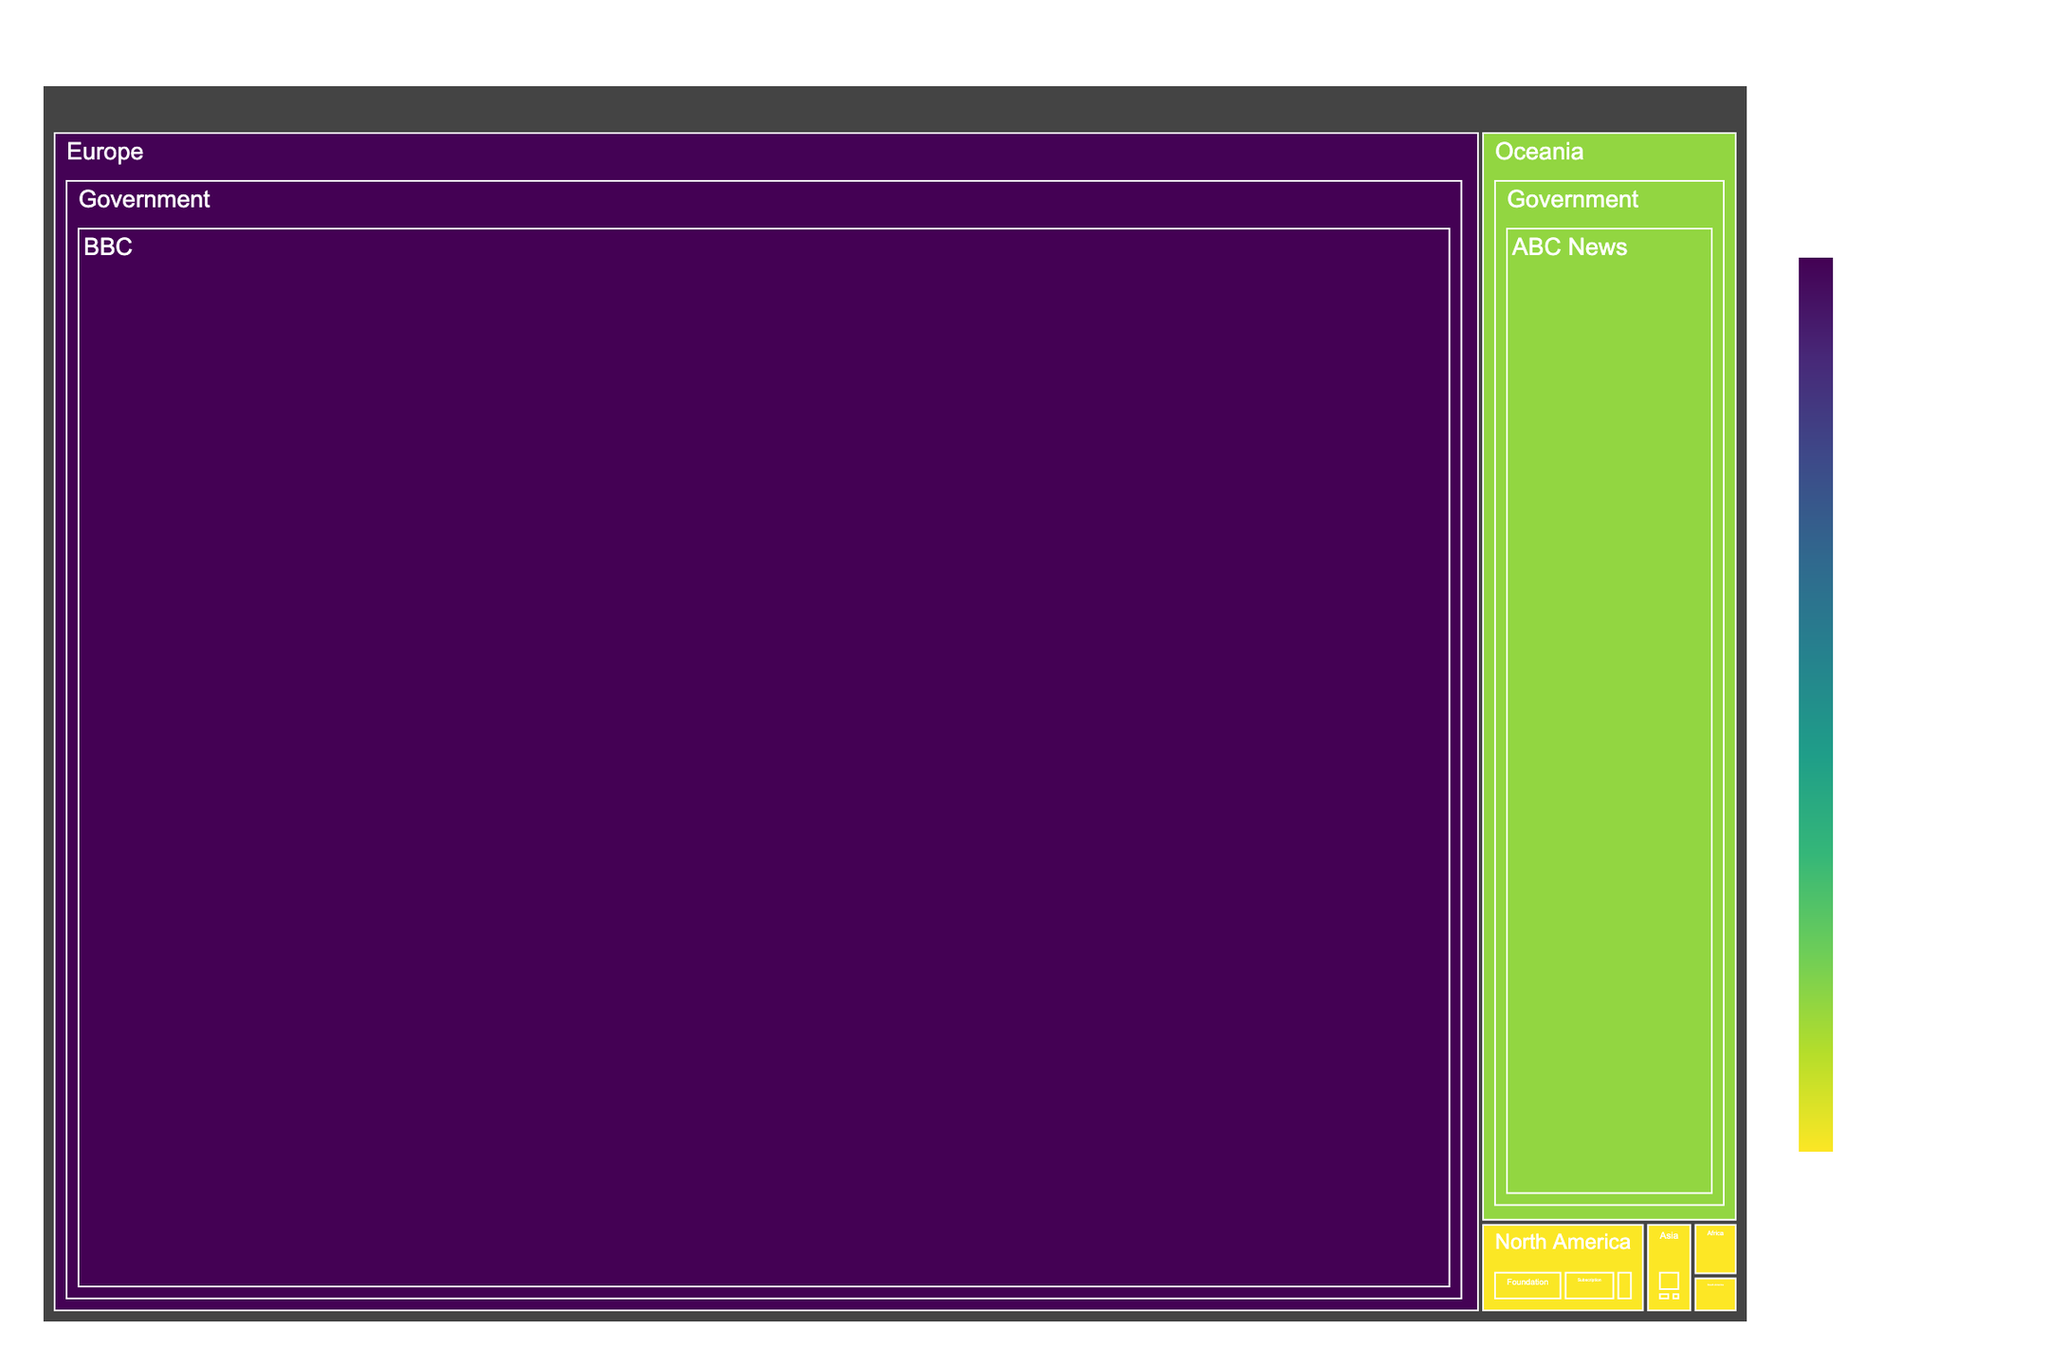what is the title of the figure? The title of a figure is usually found at the top of the figure and gives viewers an overview of what the figure represents. In this case, it reads "Funding Sources for Independent Media Outlets."
Answer: Funding Sources for Independent Media Outlets Which outlet received the highest amount of funding in the treemap? To find the outlet with the highest funding, locate the largest block on the treemap. This is usually the one with the highest value. The largest block in this case is the BBC from Europe under the Government category.
Answer: BBC How many categories of funding sources are represented in North America? To determine the number of categories, look at the different "Type" branches under the "North America" region. Here, North America has three categories: Foundation, Crowdfunding, and Subscription.
Answer: 3 What is the total funding amount for media outlets in Europe? Sum the funding amounts for all outlets located in Europe: BBC ($4,500,000,000), The Guardian ($12,000,000), and Correctiv ($3,000,000). The calculation is $4,500,000,000 + $12,000,000 + $3,000,000 which equals $4,515,000,000.
Answer: $4,515,000,000 Which region has the lowest total funding amount? To determine this, sum the funding amounts within each region and compare. South America has Nexo Jornal ($3,000,000) and La Silla Vacia ($1,500,000) totaling $4,500,000, which is less than other regions.
Answer: South America How does the funding for The Atlantic compare to The Guardian? Compare the funding amount for The Atlantic ($15,000,000) from North America with The Guardian ($12,000,000) from Europe. The Atlantic received $3,000,000 more than The Guardian.
Answer: The Atlantic has higher funding by $3,000,000 What's the difference in funding between ABC News and the South China Morning Post? Subtract the funding amount for the South China Morning Post ($8,000,000) from ABC News ($750,000,000) which results in $750,000,000 - $8,000,000 = $742,000,000.
Answer: $742,000,000 What type of funding has the highest total in Asia? Check the funding amounts in Asia for each type: Corporate (South China Morning Post $8,000,000), Foundation (Rappler $2,000,000), Subscription (The Ken $1,500,000). The Corporate type has the highest total with $8,000,000.
Answer: Corporate Which region has the greatest variety of funding types? Count the number of unique funding types in each region. North America has Foundation, Crowdfunding, and Subscription (3 types), which is more than any other region.
Answer: North America How many media outlets in total are represented in the figure? Count each unique outlet mentioned in the treemap: ProPublica, The Intercept, The Atlantic, BBC, The Guardian, Correctiv, South China Morning Post, Rappler, The Ken, Daily Maverick, Mail & Guardian, Nexo Jornal, La Silla Vacia, ABC News, Crikey – totaling 15 outlets.
Answer: 15 